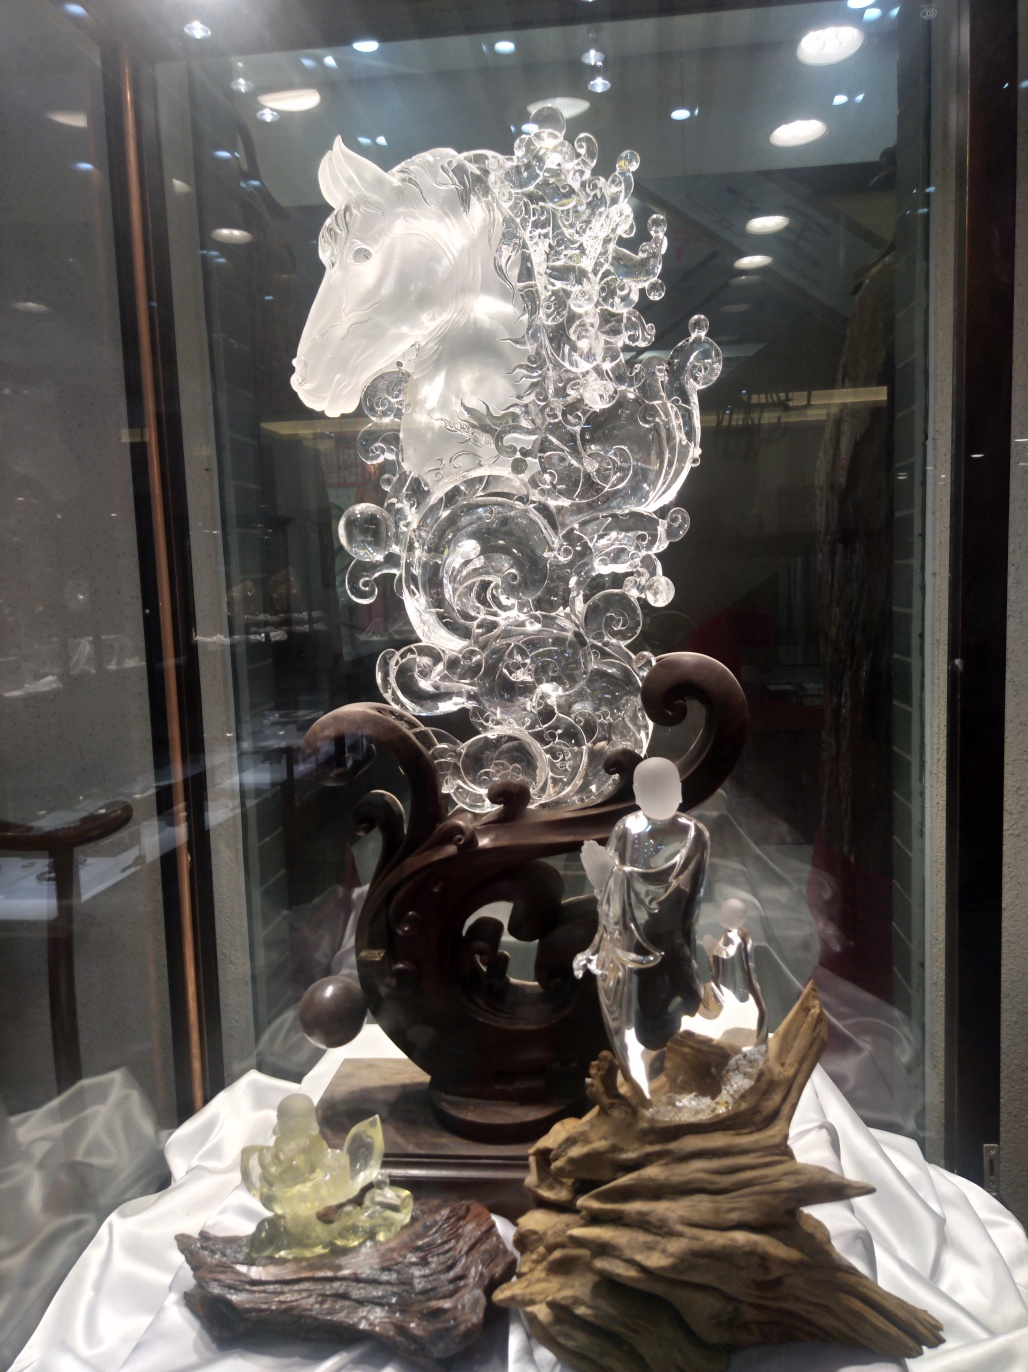What might be the occasion or setting for displaying such an item? This glass sculpture of a horse is likely displayed in an art gallery, exhibit, or a high-end shop selling fine glass art. Such an intricate piece could be a collector's item or a centerpiece for a special event celebrating craftsmanship and artistry. 